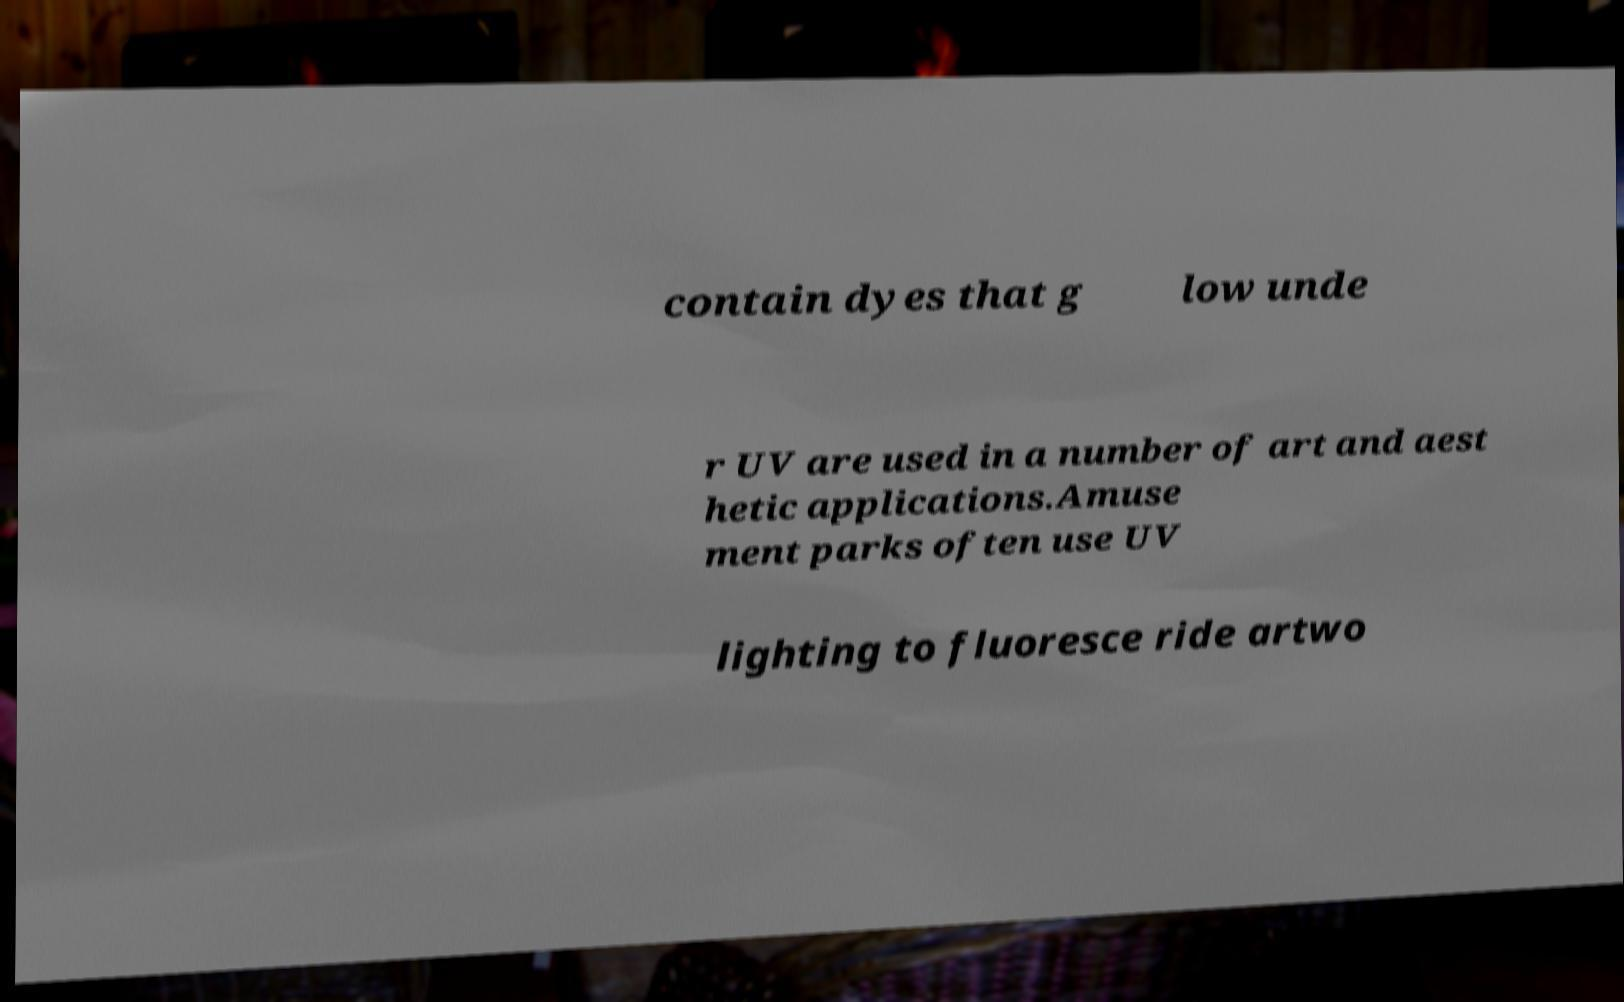There's text embedded in this image that I need extracted. Can you transcribe it verbatim? contain dyes that g low unde r UV are used in a number of art and aest hetic applications.Amuse ment parks often use UV lighting to fluoresce ride artwo 